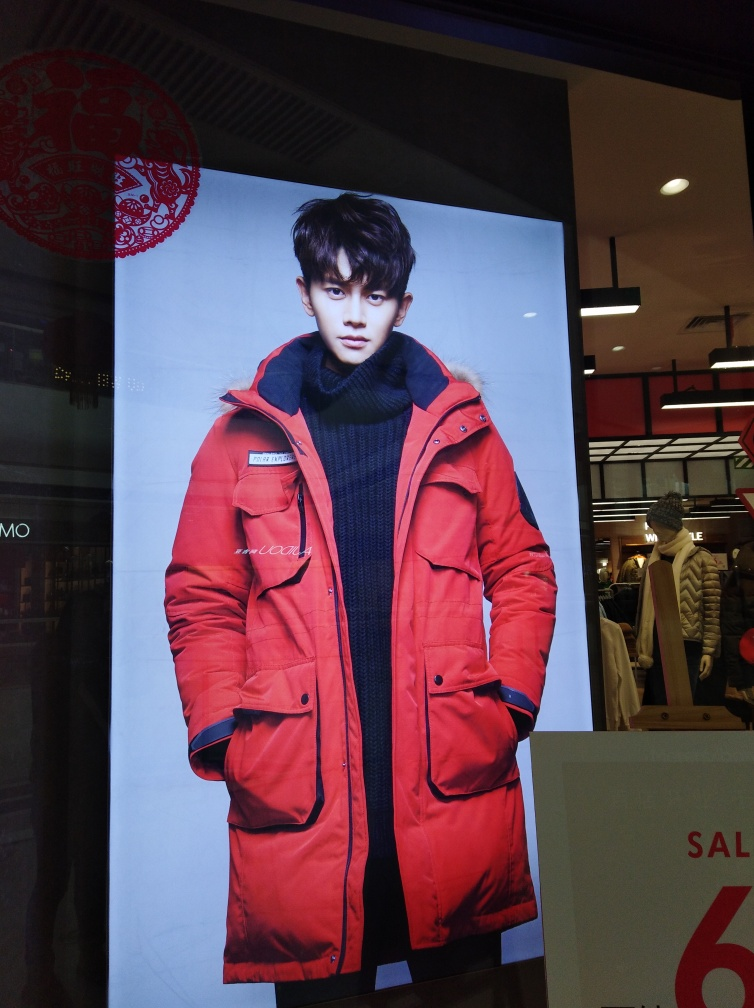What style of clothing is the person in the image wearing? The individual is wearing a contemporary winter style, highlighted by a bold red puffer jacket and a cozy turtleneck sweater. 